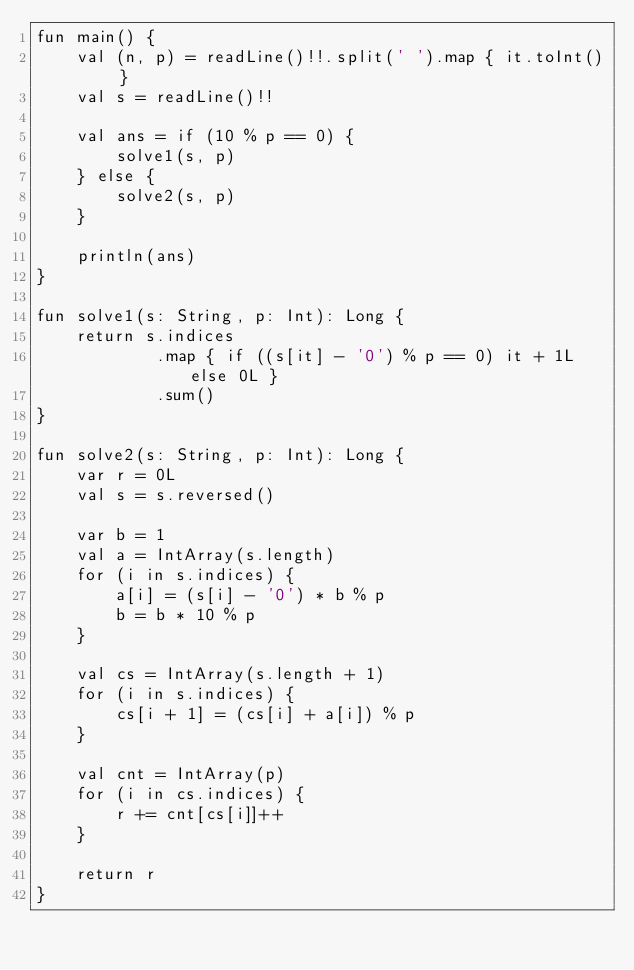<code> <loc_0><loc_0><loc_500><loc_500><_Kotlin_>fun main() {
    val (n, p) = readLine()!!.split(' ').map { it.toInt() }
    val s = readLine()!!

    val ans = if (10 % p == 0) {
        solve1(s, p)
    } else {
        solve2(s, p)
    }

    println(ans)
}

fun solve1(s: String, p: Int): Long {
    return s.indices
            .map { if ((s[it] - '0') % p == 0) it + 1L else 0L }
            .sum()
}

fun solve2(s: String, p: Int): Long {
    var r = 0L
    val s = s.reversed()

    var b = 1
    val a = IntArray(s.length)
    for (i in s.indices) {
        a[i] = (s[i] - '0') * b % p
        b = b * 10 % p
    }

    val cs = IntArray(s.length + 1)
    for (i in s.indices) {
        cs[i + 1] = (cs[i] + a[i]) % p
    }

    val cnt = IntArray(p)
    for (i in cs.indices) {
        r += cnt[cs[i]]++
    }

    return r
}
</code> 